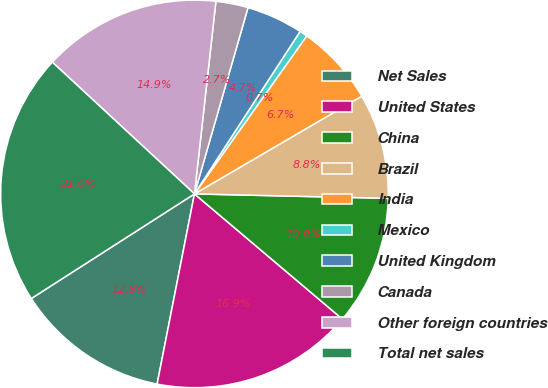<chart> <loc_0><loc_0><loc_500><loc_500><pie_chart><fcel>Net Sales<fcel>United States<fcel>China<fcel>Brazil<fcel>India<fcel>Mexico<fcel>United Kingdom<fcel>Canada<fcel>Other foreign countries<fcel>Total net sales<nl><fcel>12.84%<fcel>16.91%<fcel>10.81%<fcel>8.78%<fcel>6.75%<fcel>0.66%<fcel>4.72%<fcel>2.69%<fcel>14.87%<fcel>20.97%<nl></chart> 